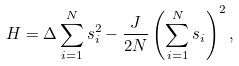Convert formula to latex. <formula><loc_0><loc_0><loc_500><loc_500>H = \Delta \sum _ { i = 1 } ^ { N } s _ { i } ^ { 2 } - \frac { J } { 2 N } \left ( \sum _ { i = 1 } ^ { N } s _ { i } \right ) ^ { 2 } ,</formula> 